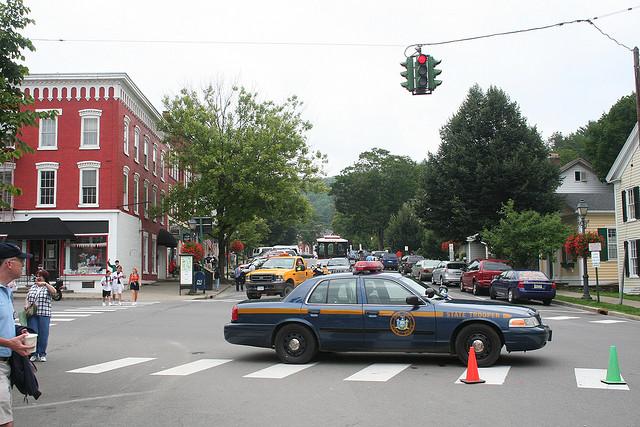What is the tow truck going to tow?
Concise answer only. Car. How many people are in the street?
Give a very brief answer. 6. What might happen if the blue truck turns left too fast?
Give a very brief answer. Accident. What color are the cones?
Give a very brief answer. Orange and green. Are people wearing shorts?
Give a very brief answer. Yes. Is the police car still or in motion?
Give a very brief answer. Yes. What is the color of the traffic light?
Keep it brief. Red. Is this traffic located in America?
Give a very brief answer. Yes. 